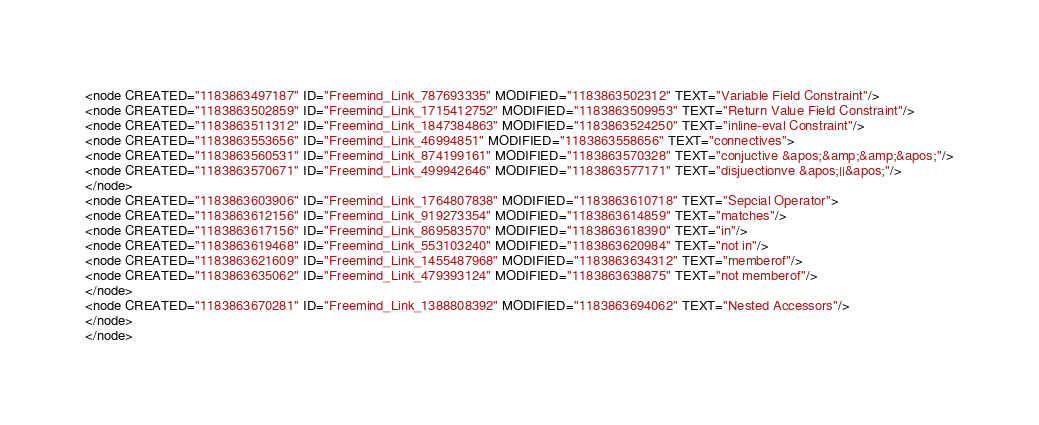Convert code to text. <code><loc_0><loc_0><loc_500><loc_500><_ObjectiveC_><node CREATED="1183863497187" ID="Freemind_Link_787693335" MODIFIED="1183863502312" TEXT="Variable Field Constraint"/>
<node CREATED="1183863502859" ID="Freemind_Link_1715412752" MODIFIED="1183863509953" TEXT="Return Value Field Constraint"/>
<node CREATED="1183863511312" ID="Freemind_Link_1847384863" MODIFIED="1183863524250" TEXT="inline-eval Constraint"/>
<node CREATED="1183863553656" ID="Freemind_Link_46994851" MODIFIED="1183863558656" TEXT="connectives">
<node CREATED="1183863560531" ID="Freemind_Link_874199161" MODIFIED="1183863570328" TEXT="conjuctive &apos;&amp;&amp;&apos;"/>
<node CREATED="1183863570671" ID="Freemind_Link_499942646" MODIFIED="1183863577171" TEXT="disjuectionve &apos;||&apos;"/>
</node>
<node CREATED="1183863603906" ID="Freemind_Link_1764807838" MODIFIED="1183863610718" TEXT="Sepcial Operator">
<node CREATED="1183863612156" ID="Freemind_Link_919273354" MODIFIED="1183863614859" TEXT="matches"/>
<node CREATED="1183863617156" ID="Freemind_Link_869583570" MODIFIED="1183863618390" TEXT="in"/>
<node CREATED="1183863619468" ID="Freemind_Link_553103240" MODIFIED="1183863620984" TEXT="not in"/>
<node CREATED="1183863621609" ID="Freemind_Link_1455487968" MODIFIED="1183863634312" TEXT="memberof"/>
<node CREATED="1183863635062" ID="Freemind_Link_479393124" MODIFIED="1183863638875" TEXT="not memberof"/>
</node>
<node CREATED="1183863670281" ID="Freemind_Link_1388808392" MODIFIED="1183863694062" TEXT="Nested Accessors"/>
</node>
</node></code> 